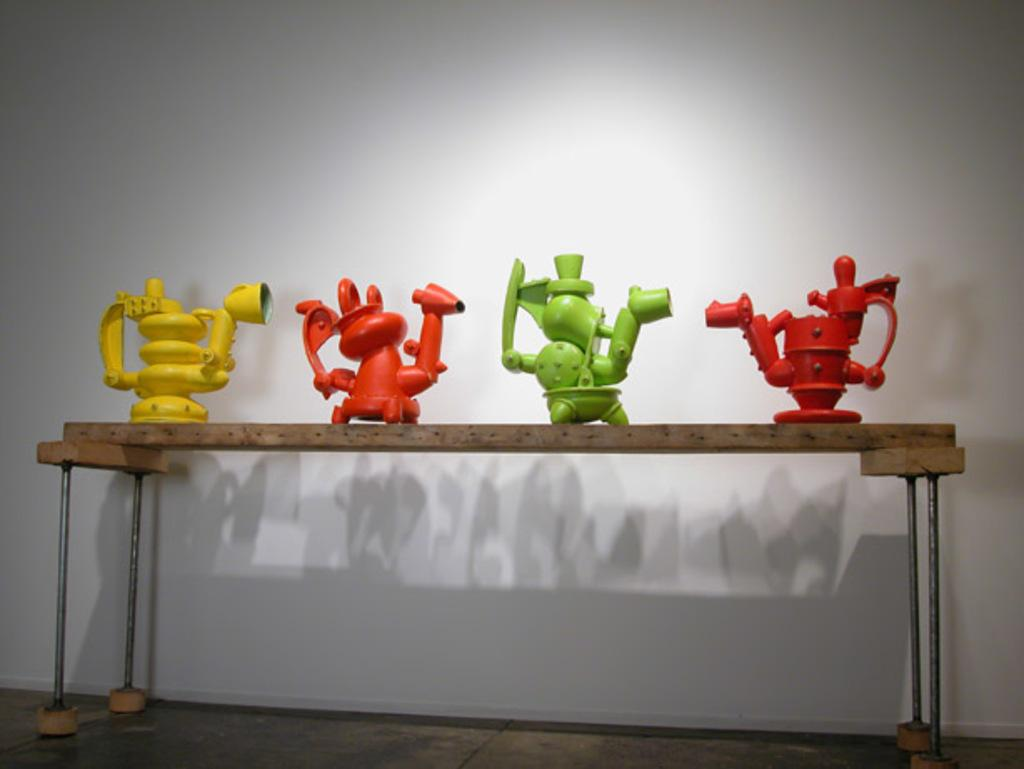How many toys are visible in the image? There are four colored toys in the image. Where are the toys located? The toys are on a table. How many cats are sitting on the mailbox in the image? There are no cats or mailboxes present in the image. 